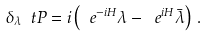<formula> <loc_0><loc_0><loc_500><loc_500>\delta _ { \lambda } \ t P = i \left ( \ e ^ { - i H } \lambda - \ e ^ { i H } \bar { \lambda } \right ) \, .</formula> 